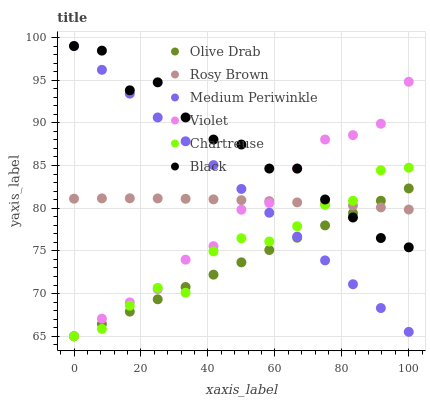Does Olive Drab have the minimum area under the curve?
Answer yes or no. Yes. Does Black have the maximum area under the curve?
Answer yes or no. Yes. Does Medium Periwinkle have the minimum area under the curve?
Answer yes or no. No. Does Medium Periwinkle have the maximum area under the curve?
Answer yes or no. No. Is Olive Drab the smoothest?
Answer yes or no. Yes. Is Black the roughest?
Answer yes or no. Yes. Is Medium Periwinkle the smoothest?
Answer yes or no. No. Is Medium Periwinkle the roughest?
Answer yes or no. No. Does Chartreuse have the lowest value?
Answer yes or no. Yes. Does Medium Periwinkle have the lowest value?
Answer yes or no. No. Does Black have the highest value?
Answer yes or no. Yes. Does Chartreuse have the highest value?
Answer yes or no. No. Does Black intersect Rosy Brown?
Answer yes or no. Yes. Is Black less than Rosy Brown?
Answer yes or no. No. Is Black greater than Rosy Brown?
Answer yes or no. No. 